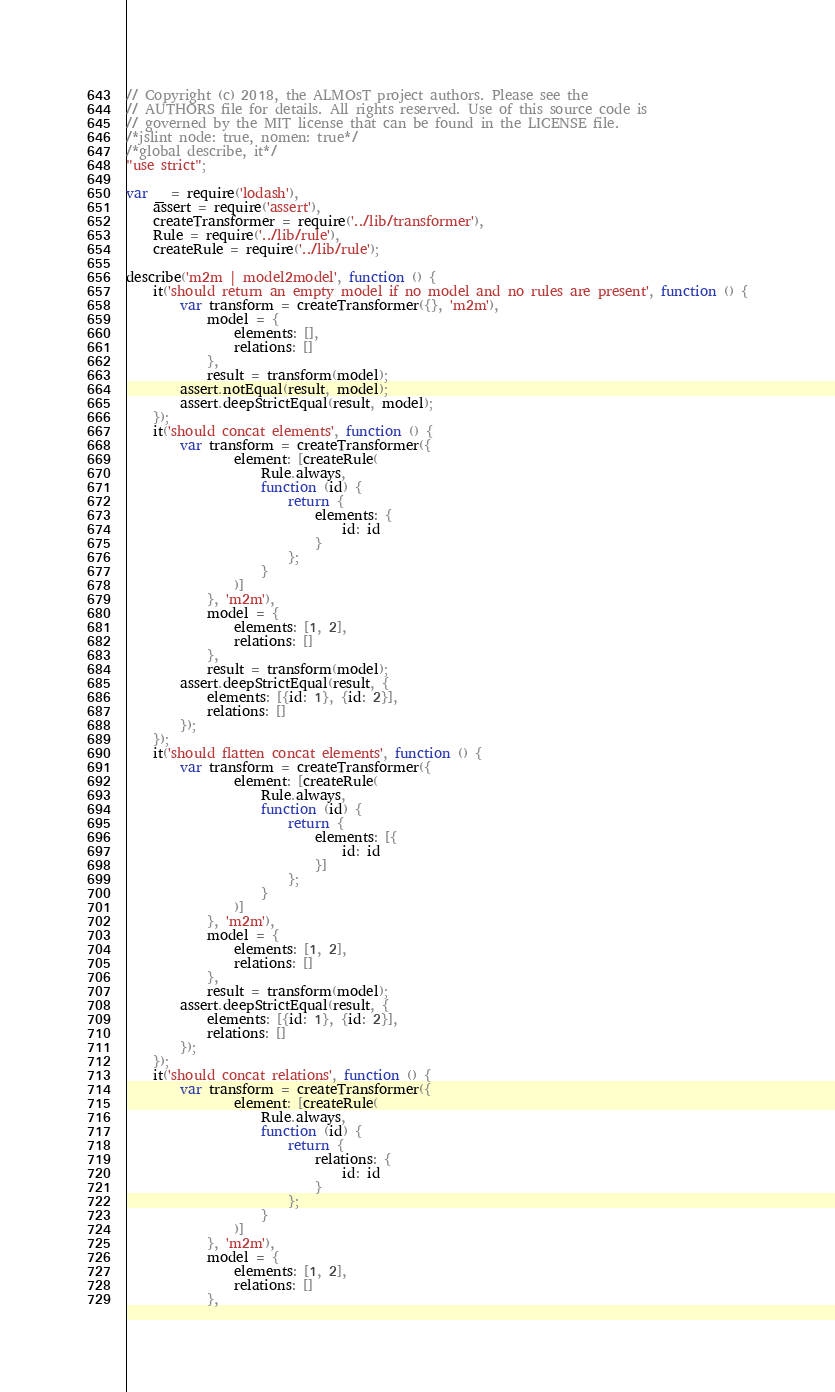<code> <loc_0><loc_0><loc_500><loc_500><_JavaScript_>// Copyright (c) 2018, the ALMOsT project authors. Please see the
// AUTHORS file for details. All rights reserved. Use of this source code is
// governed by the MIT license that can be found in the LICENSE file.
/*jslint node: true, nomen: true*/
/*global describe, it*/
"use strict";

var _ = require('lodash'),
    assert = require('assert'),
    createTransformer = require('../lib/transformer'),
    Rule = require('../lib/rule'),
    createRule = require('../lib/rule');

describe('m2m | model2model', function () {
    it('should return an empty model if no model and no rules are present', function () {
        var transform = createTransformer({}, 'm2m'),
            model = {
                elements: [],
                relations: []
            },
            result = transform(model);
        assert.notEqual(result, model);
        assert.deepStrictEqual(result, model);
    });
    it('should concat elements', function () {
        var transform = createTransformer({
                element: [createRule(
                    Rule.always,
                    function (id) {
                        return {
                            elements: {
                                id: id
                            }
                        };
                    }
                )]
            }, 'm2m'),
            model = {
                elements: [1, 2],
                relations: []
            },
            result = transform(model);
        assert.deepStrictEqual(result, {
            elements: [{id: 1}, {id: 2}],
            relations: []
        });
    });
    it('should flatten concat elements', function () {
        var transform = createTransformer({
                element: [createRule(
                    Rule.always,
                    function (id) {
                        return {
                            elements: [{
                                id: id
                            }]
                        };
                    }
                )]
            }, 'm2m'),
            model = {
                elements: [1, 2],
                relations: []
            },
            result = transform(model);
        assert.deepStrictEqual(result, {
            elements: [{id: 1}, {id: 2}],
            relations: []
        });
    });
    it('should concat relations', function () {
        var transform = createTransformer({
                element: [createRule(
                    Rule.always,
                    function (id) {
                        return {
                            relations: {
                                id: id
                            }
                        };
                    }
                )]
            }, 'm2m'),
            model = {
                elements: [1, 2],
                relations: []
            },</code> 